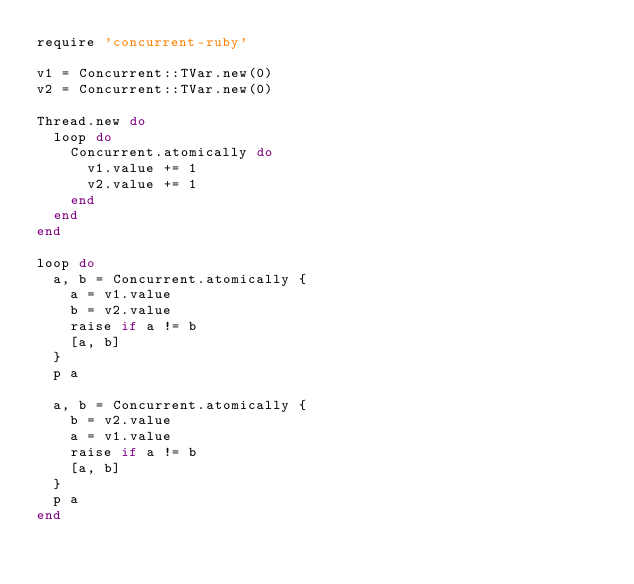Convert code to text. <code><loc_0><loc_0><loc_500><loc_500><_Ruby_>require 'concurrent-ruby'

v1 = Concurrent::TVar.new(0)
v2 = Concurrent::TVar.new(0)

Thread.new do
  loop do
    Concurrent.atomically do
      v1.value += 1
      v2.value += 1
    end
  end
end

loop do
  a, b = Concurrent.atomically {
    a = v1.value
    b = v2.value
    raise if a != b
    [a, b]
  }
  p a

  a, b = Concurrent.atomically {
    b = v2.value
    a = v1.value
    raise if a != b
    [a, b]
  }
  p a
end
</code> 